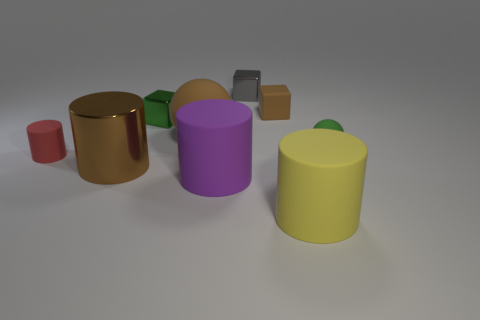Subtract all cyan cylinders. Subtract all brown balls. How many cylinders are left? 4 Add 1 small brown rubber things. How many objects exist? 10 Subtract all blocks. How many objects are left? 6 Add 5 gray blocks. How many gray blocks are left? 6 Add 9 green balls. How many green balls exist? 10 Subtract 0 red blocks. How many objects are left? 9 Subtract all tiny gray matte cubes. Subtract all small green things. How many objects are left? 7 